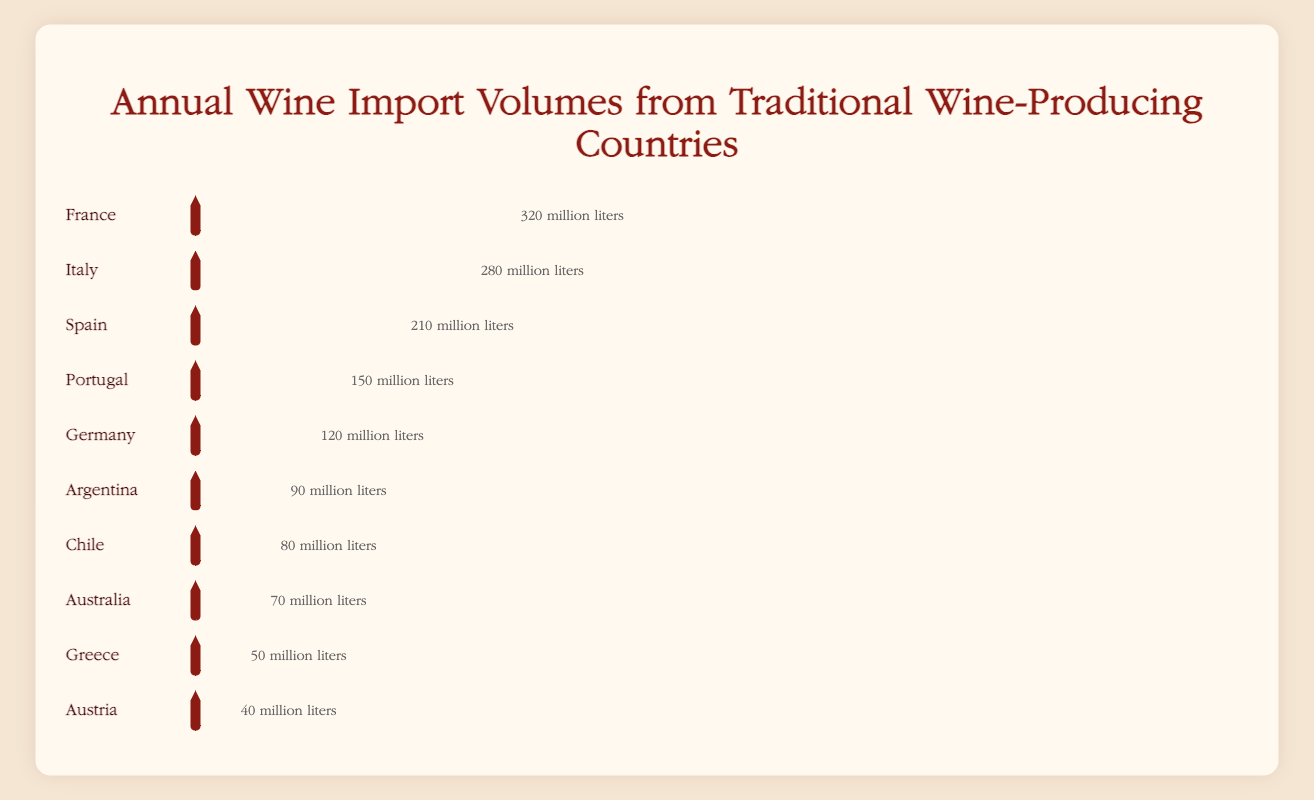Which country has the highest wine import volume? Look for the country with the longest bottle representation in the plot. France has the longest bottle representation.
Answer: France What's the combined import volume of wine from Spain and Portugal? Identify the import volumes for Spain (210 million liters) and Portugal (150 million liters) and sum them up: 210 + 150.
Answer: 360 million liters Which country imports more wine, Germany or Argentina? Compare the bottle sizes for Germany (120 million liters) and Argentina (90 million liters). Germany has the larger bottle.
Answer: Germany What is the import volume difference between Italy and Australia? Find the import volumes for Italy (280 million liters) and Australia (70 million liters), then subtract the smaller from the larger: 280 - 70.
Answer: 210 million liters How many countries have an import volume of less than 100 million liters? Identify and count the countries with bottle sizes representing under 100 million liters: Argentina, Chile, Australia, Greece, and Austria (5 countries).
Answer: 5 Which country has the smallest wine import volume? Look for the country with the shortest bottle representation in the plot. Austria has the shortest bottle representation.
Answer: Austria What is the average import volume for the top 3 countries? Identify the import volumes for the top 3 countries: France (320 million liters), Italy (280 million liters), and Spain (210 million liters). Sum them up and divide by 3: (320 + 280 + 210) / 3.
Answer: 270 million liters Which countries import more than 150 million liters of wine? Identify the countries with bottle sizes representing over 150 million liters: France, Italy, and Spain.
Answer: France, Italy, Spain How much more wine does Portugal import than Austria? Find the import volumes for Portugal (150 million liters) and Austria (40 million liters), then subtract the smaller from the larger: 150 - 40.
Answer: 110 million liters What's the total import volume of wine from all the countries listed? Sum the import volumes of all the countries: 320 + 280 + 210 + 150 + 120 + 90 + 80 + 70 + 50 + 40.
Answer: 1410 million liters 